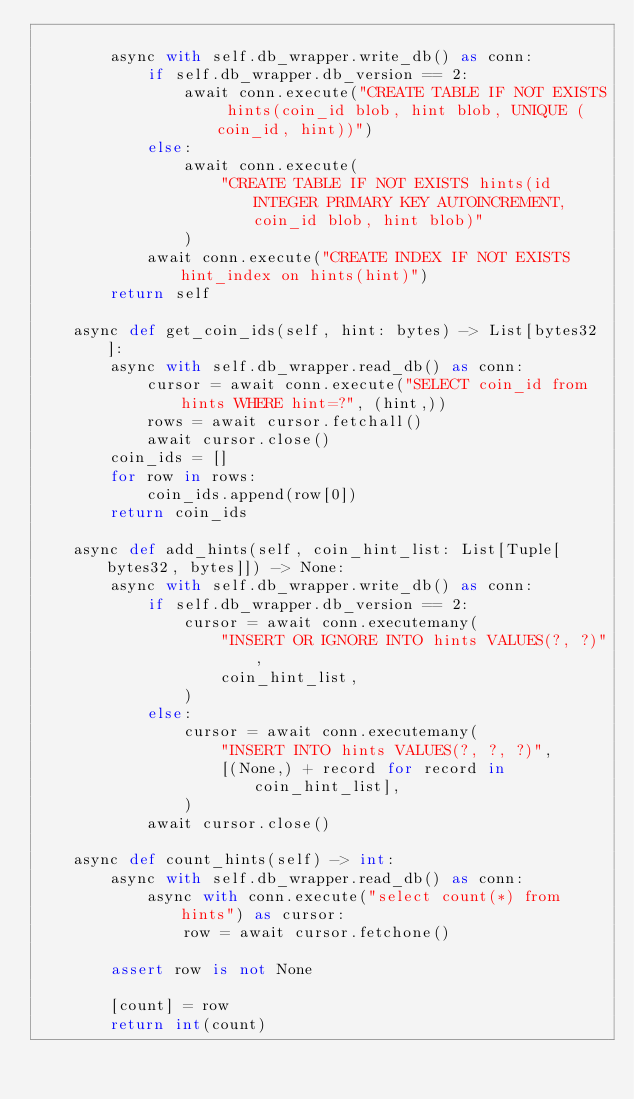<code> <loc_0><loc_0><loc_500><loc_500><_Python_>
        async with self.db_wrapper.write_db() as conn:
            if self.db_wrapper.db_version == 2:
                await conn.execute("CREATE TABLE IF NOT EXISTS hints(coin_id blob, hint blob, UNIQUE (coin_id, hint))")
            else:
                await conn.execute(
                    "CREATE TABLE IF NOT EXISTS hints(id INTEGER PRIMARY KEY AUTOINCREMENT, coin_id blob, hint blob)"
                )
            await conn.execute("CREATE INDEX IF NOT EXISTS hint_index on hints(hint)")
        return self

    async def get_coin_ids(self, hint: bytes) -> List[bytes32]:
        async with self.db_wrapper.read_db() as conn:
            cursor = await conn.execute("SELECT coin_id from hints WHERE hint=?", (hint,))
            rows = await cursor.fetchall()
            await cursor.close()
        coin_ids = []
        for row in rows:
            coin_ids.append(row[0])
        return coin_ids

    async def add_hints(self, coin_hint_list: List[Tuple[bytes32, bytes]]) -> None:
        async with self.db_wrapper.write_db() as conn:
            if self.db_wrapper.db_version == 2:
                cursor = await conn.executemany(
                    "INSERT OR IGNORE INTO hints VALUES(?, ?)",
                    coin_hint_list,
                )
            else:
                cursor = await conn.executemany(
                    "INSERT INTO hints VALUES(?, ?, ?)",
                    [(None,) + record for record in coin_hint_list],
                )
            await cursor.close()

    async def count_hints(self) -> int:
        async with self.db_wrapper.read_db() as conn:
            async with conn.execute("select count(*) from hints") as cursor:
                row = await cursor.fetchone()

        assert row is not None

        [count] = row
        return int(count)
</code> 